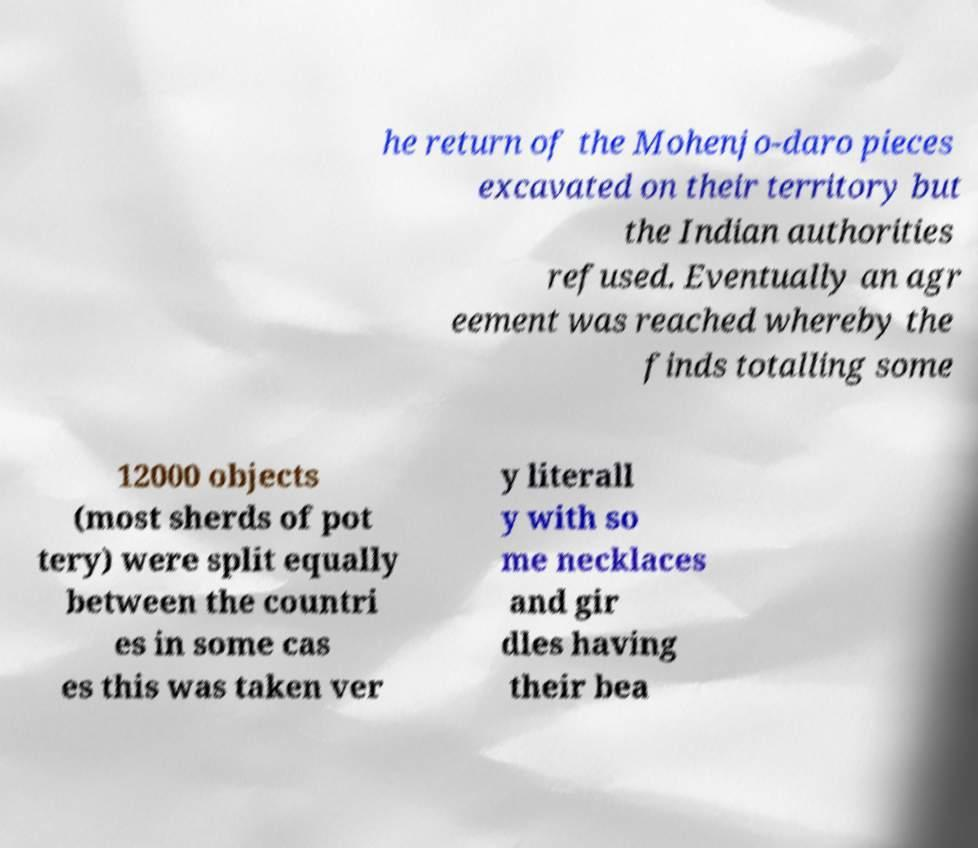Could you extract and type out the text from this image? he return of the Mohenjo-daro pieces excavated on their territory but the Indian authorities refused. Eventually an agr eement was reached whereby the finds totalling some 12000 objects (most sherds of pot tery) were split equally between the countri es in some cas es this was taken ver y literall y with so me necklaces and gir dles having their bea 